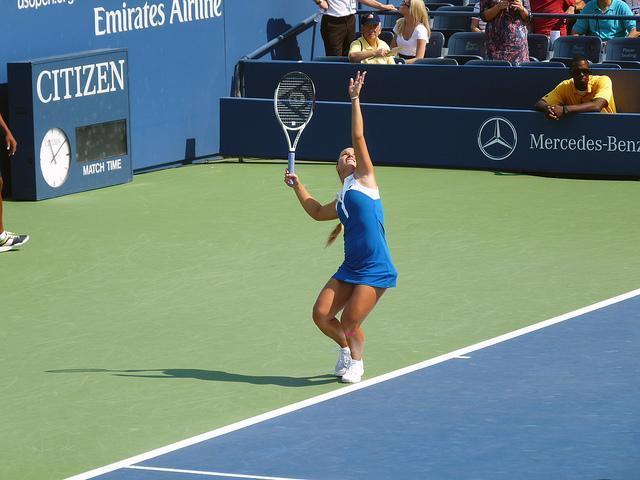How many people are in the photo?
Give a very brief answer. 4. 